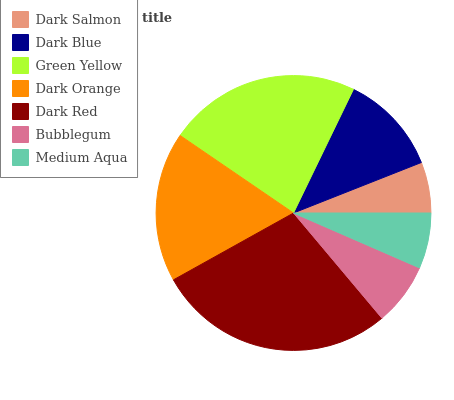Is Dark Salmon the minimum?
Answer yes or no. Yes. Is Dark Red the maximum?
Answer yes or no. Yes. Is Dark Blue the minimum?
Answer yes or no. No. Is Dark Blue the maximum?
Answer yes or no. No. Is Dark Blue greater than Dark Salmon?
Answer yes or no. Yes. Is Dark Salmon less than Dark Blue?
Answer yes or no. Yes. Is Dark Salmon greater than Dark Blue?
Answer yes or no. No. Is Dark Blue less than Dark Salmon?
Answer yes or no. No. Is Dark Blue the high median?
Answer yes or no. Yes. Is Dark Blue the low median?
Answer yes or no. Yes. Is Dark Salmon the high median?
Answer yes or no. No. Is Green Yellow the low median?
Answer yes or no. No. 